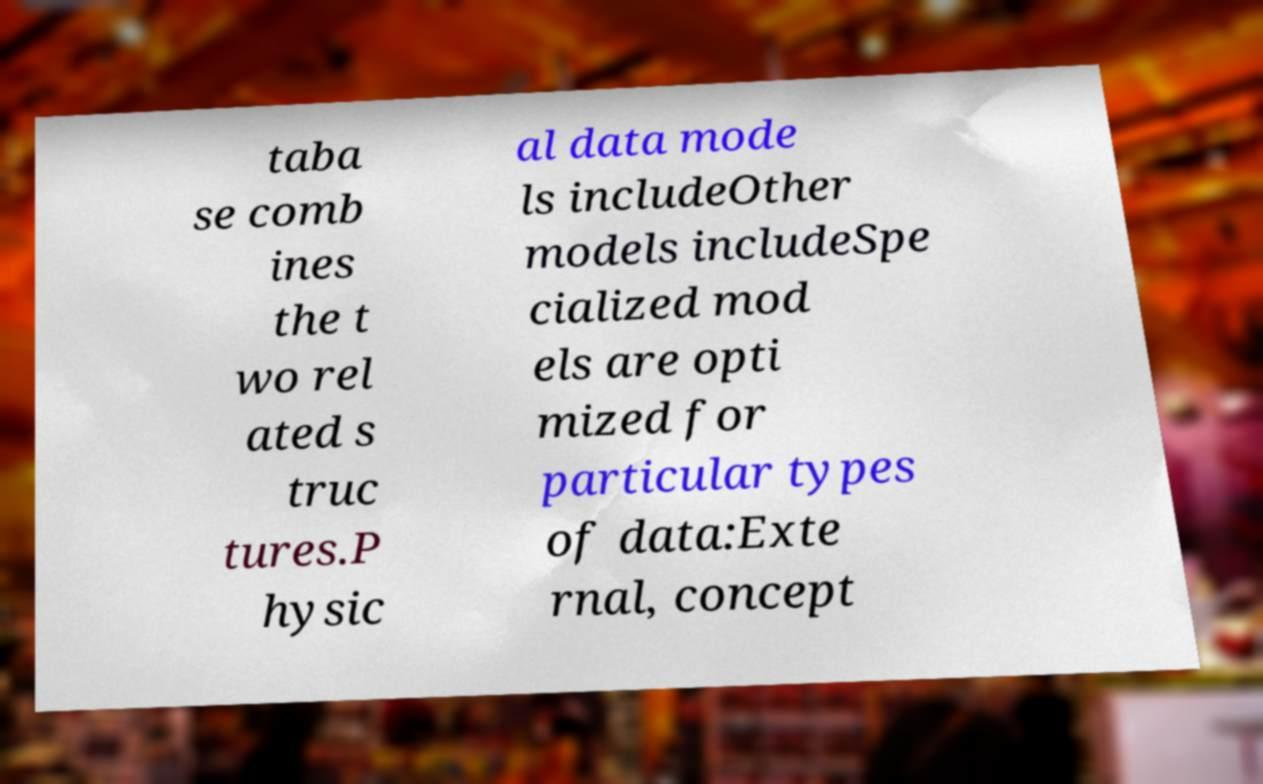Can you read and provide the text displayed in the image?This photo seems to have some interesting text. Can you extract and type it out for me? taba se comb ines the t wo rel ated s truc tures.P hysic al data mode ls includeOther models includeSpe cialized mod els are opti mized for particular types of data:Exte rnal, concept 